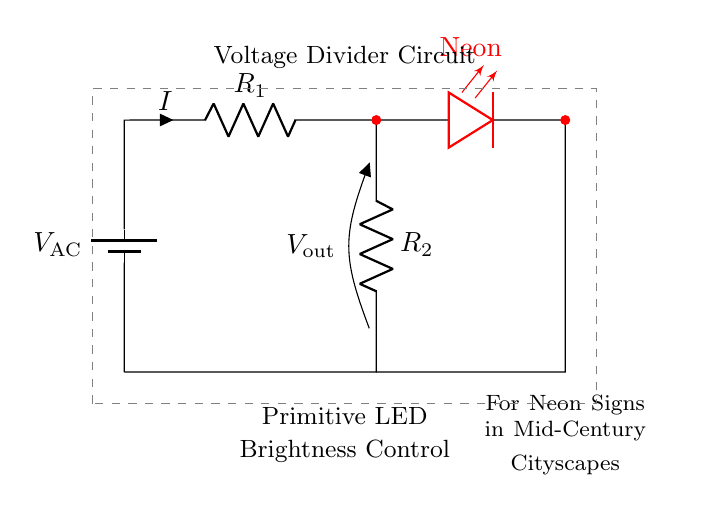What is the type of the first component in the circuit? The first component in the circuit is a battery, indicated by the symbol 'V_AC' which represents the voltage source for alternating current.
Answer: Battery What is the function of the resistors in this circuit? The resistors in this voltage divider circuit function to control the current and set the voltage across the LED. Their values determine the brightness of the neon sign by dividing the input voltage.
Answer: Current control What is the output voltage across the LED for this circuit? The output voltage is labeled as 'V_out' in the diagram, indicating the voltage drop across the second resistor and the LED.
Answer: V_out If resistor R1 is increased, what happens to the LED brightness? If R1 increases, the total resistance in the circuit increases, resulting in a lower current flowing through the LED, which would make it dimmer.
Answer: Decreases What is the relationship between R1 and R2 in determining the output voltage? The output voltage is determined by the ratio of the resistors R1 and R2 through the voltage divider formula, where V_out is a fraction of the input voltage based on these resistances.
Answer: Voltage divider formula How many components are in this circuit? There are four main components in the circuit: one battery and three others (two resistors and one LED).
Answer: Four What color is the LED in this circuit diagram? The LED in this circuit is colored red, as indicated by the text 'color=red' next to the LED symbol.
Answer: Red 